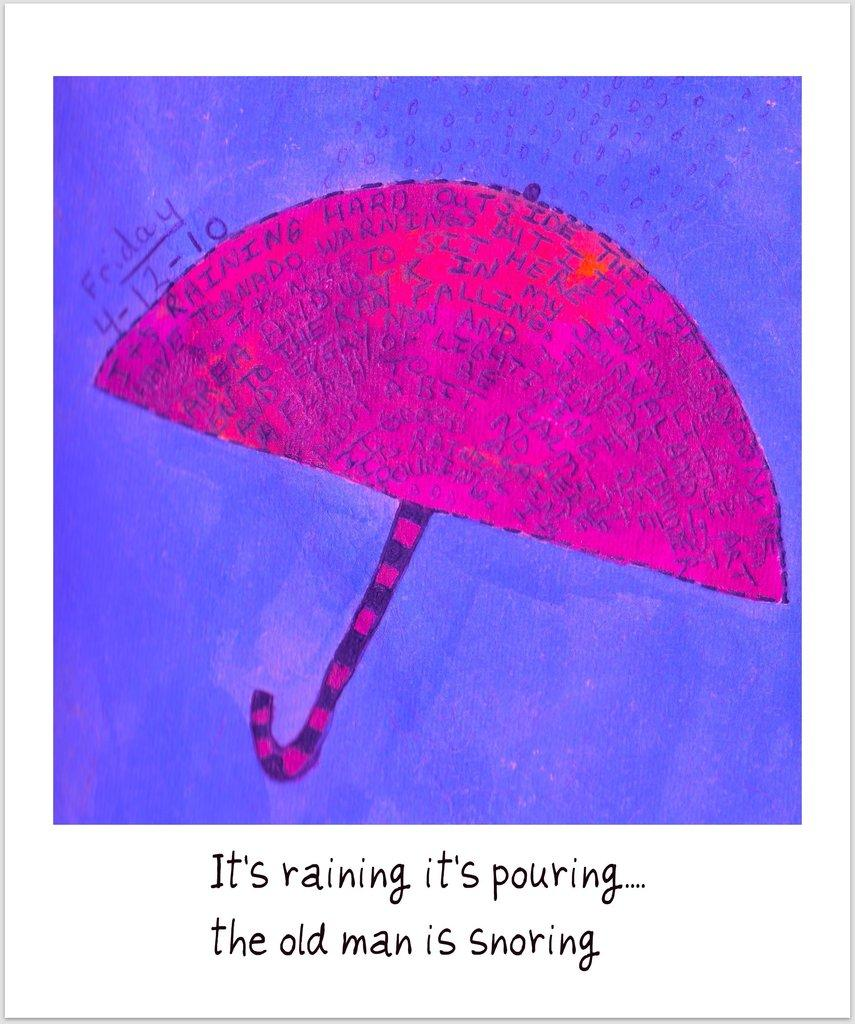What is depicted in the painting in the image? There is a painting of an umbrella in the image. Can you describe any additional details about the umbrella in the painting? There is script on the umbrella in the painting. What size pencil is your dad using to draw the painting in the image? The facts provided do not mention a pencil or your dad, so we cannot determine the size of the pencil or who is drawing the painting. 